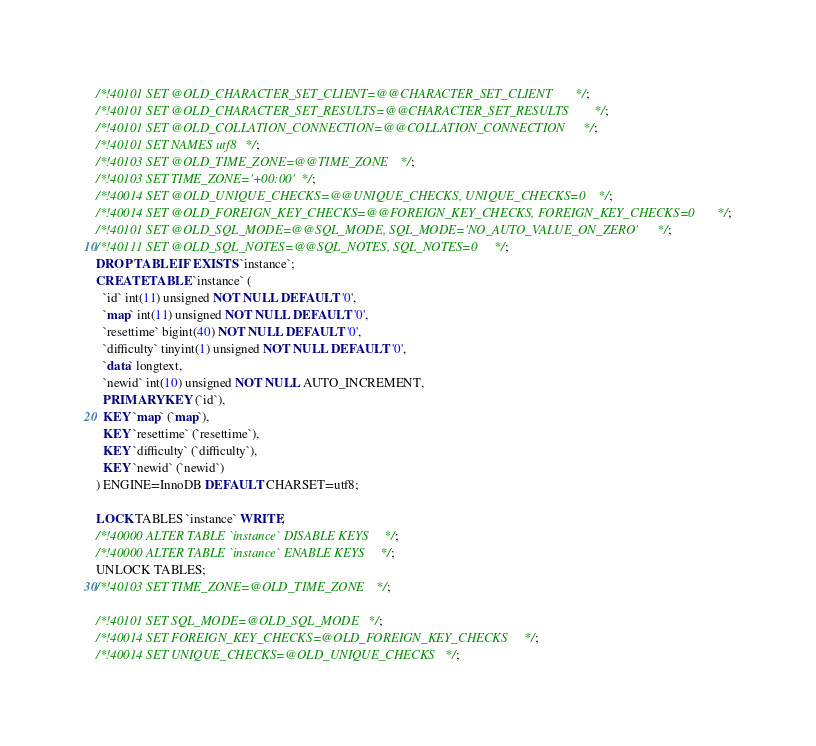Convert code to text. <code><loc_0><loc_0><loc_500><loc_500><_SQL_>
/*!40101 SET @OLD_CHARACTER_SET_CLIENT=@@CHARACTER_SET_CLIENT */;
/*!40101 SET @OLD_CHARACTER_SET_RESULTS=@@CHARACTER_SET_RESULTS */;
/*!40101 SET @OLD_COLLATION_CONNECTION=@@COLLATION_CONNECTION */;
/*!40101 SET NAMES utf8 */;
/*!40103 SET @OLD_TIME_ZONE=@@TIME_ZONE */;
/*!40103 SET TIME_ZONE='+00:00' */;
/*!40014 SET @OLD_UNIQUE_CHECKS=@@UNIQUE_CHECKS, UNIQUE_CHECKS=0 */;
/*!40014 SET @OLD_FOREIGN_KEY_CHECKS=@@FOREIGN_KEY_CHECKS, FOREIGN_KEY_CHECKS=0 */;
/*!40101 SET @OLD_SQL_MODE=@@SQL_MODE, SQL_MODE='NO_AUTO_VALUE_ON_ZERO' */;
/*!40111 SET @OLD_SQL_NOTES=@@SQL_NOTES, SQL_NOTES=0 */;
DROP TABLE IF EXISTS `instance`;
CREATE TABLE `instance` (
  `id` int(11) unsigned NOT NULL DEFAULT '0',
  `map` int(11) unsigned NOT NULL DEFAULT '0',
  `resettime` bigint(40) NOT NULL DEFAULT '0',
  `difficulty` tinyint(1) unsigned NOT NULL DEFAULT '0',
  `data` longtext,
  `newid` int(10) unsigned NOT NULL AUTO_INCREMENT,
  PRIMARY KEY (`id`),
  KEY `map` (`map`),
  KEY `resettime` (`resettime`),
  KEY `difficulty` (`difficulty`),
  KEY `newid` (`newid`)
) ENGINE=InnoDB DEFAULT CHARSET=utf8;

LOCK TABLES `instance` WRITE;
/*!40000 ALTER TABLE `instance` DISABLE KEYS */;
/*!40000 ALTER TABLE `instance` ENABLE KEYS */;
UNLOCK TABLES;
/*!40103 SET TIME_ZONE=@OLD_TIME_ZONE */;

/*!40101 SET SQL_MODE=@OLD_SQL_MODE */;
/*!40014 SET FOREIGN_KEY_CHECKS=@OLD_FOREIGN_KEY_CHECKS */;
/*!40014 SET UNIQUE_CHECKS=@OLD_UNIQUE_CHECKS */;</code> 